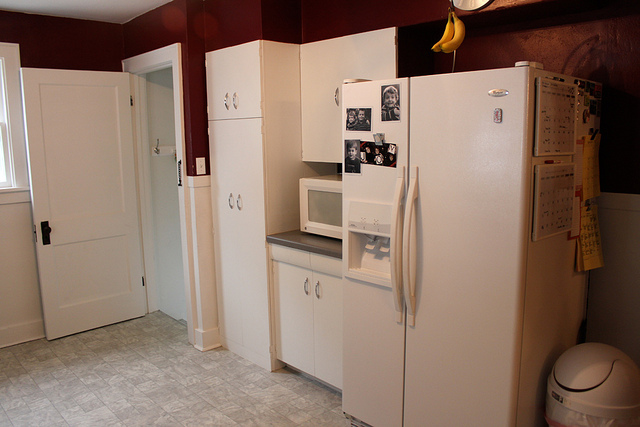Does this kitchen seem to be in a house or an apartment? It's difficult to determine with certainty from this single image alone, but the compact space and the style of the appliances and cabinets suggest it could be an apartment kitchen. Are there any personal items that make this kitchen look lived-in? Yes, there are magnetic letters on the refrigerator, some items pinned to the fridge door, photographs, and a calendar, all of which give the kitchen a personal, lived-in feel. 